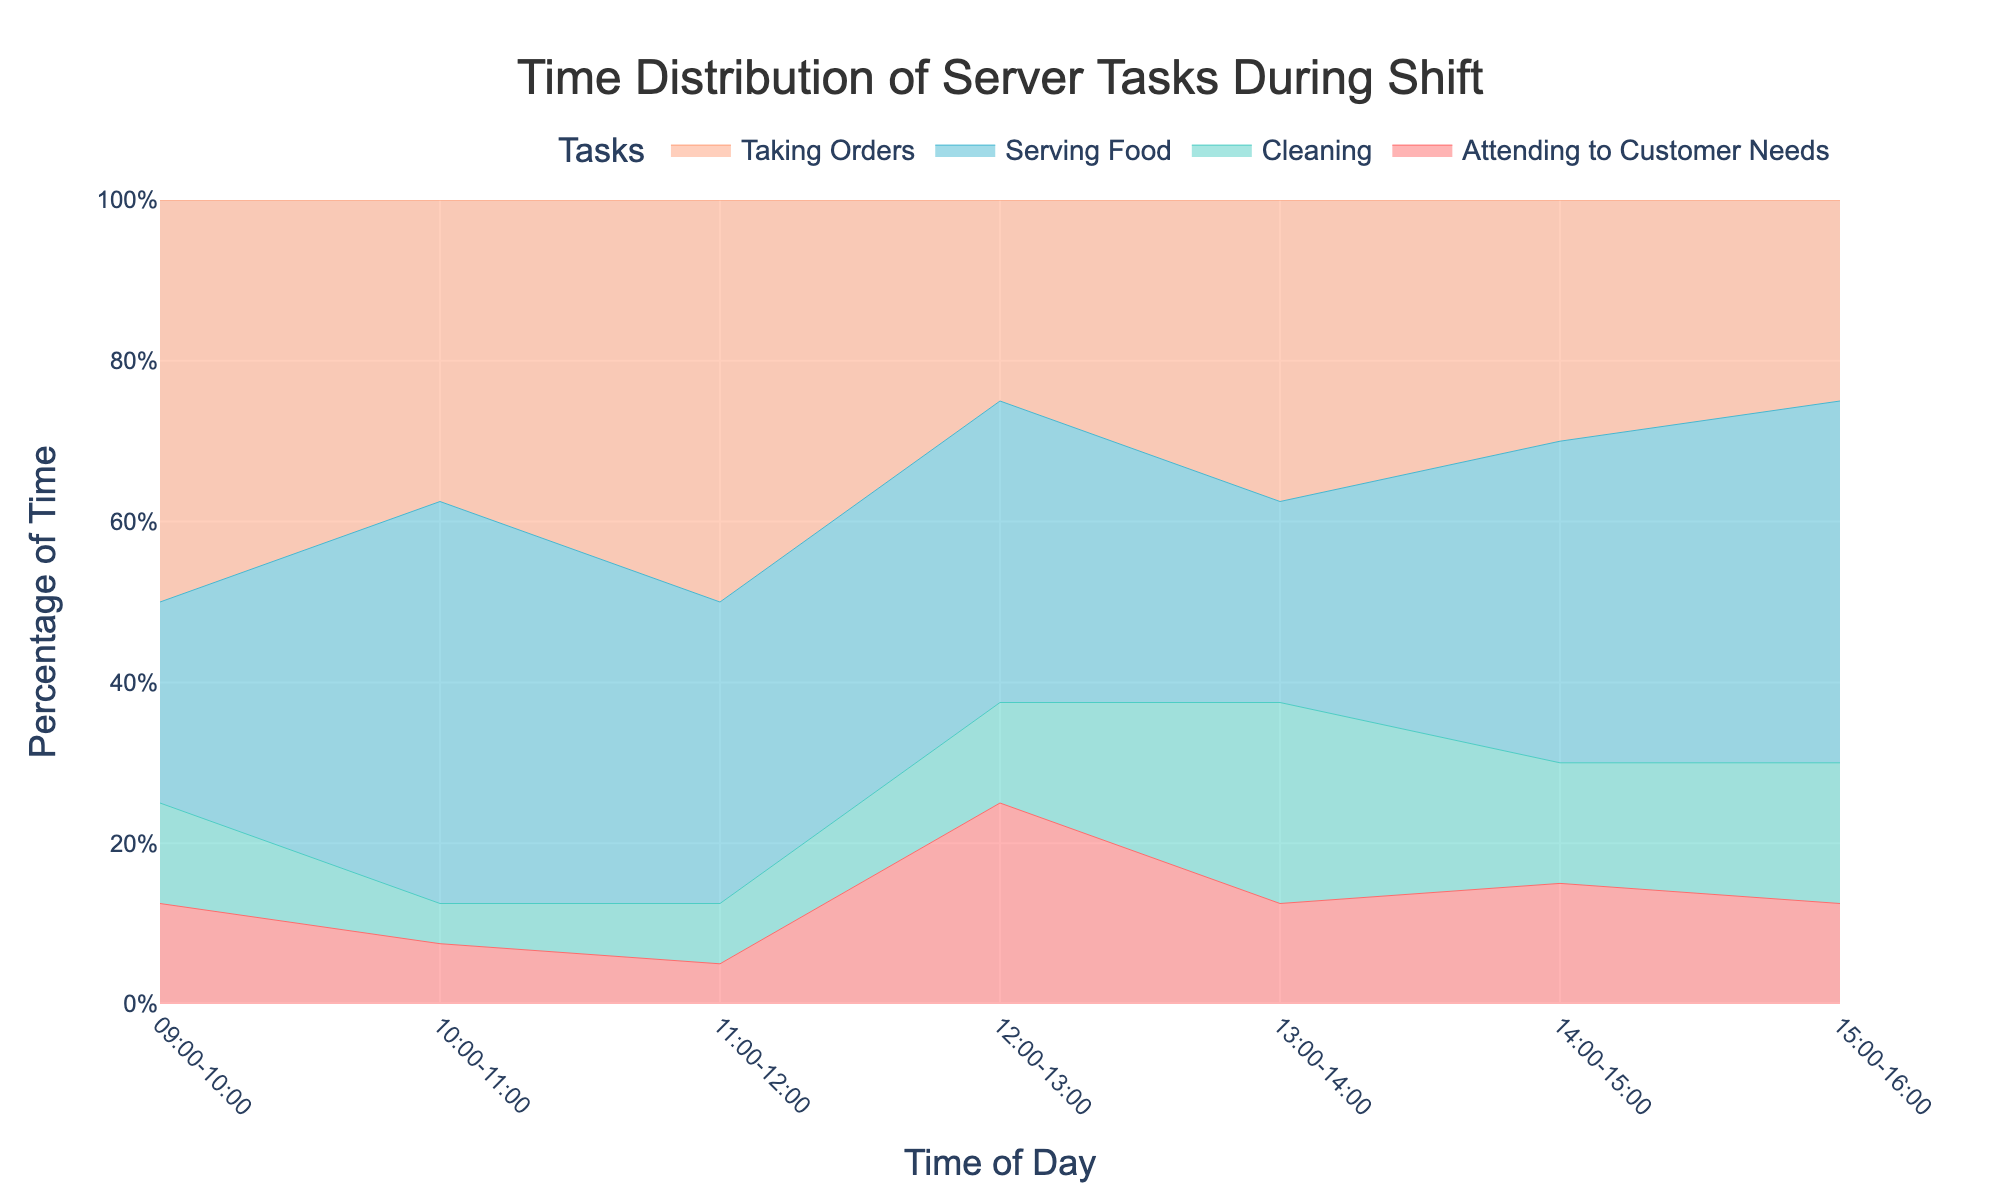What's the title of the figure? The title is usually displayed at the top center of the figure.
Answer: Time Distribution of Server Tasks During Shift What is the percentage of time spent on 'Taking Orders' between 14:00 and 15:00? Locate the period '14:00-15:00' on the x-axis and find the segment corresponding to 'Taking Orders' on the stacked area. Read the percentage from the y-axis grid lines.
Answer: 30% What task takes the most percentage of time during 12:00-13:00? Identify the 12:00-13:00 segment on the x-axis and determine which task segment extends furthest up, indicating the highest percentage.
Answer: Attending to Customer Needs What's the sum of percentages for 'Cleaning' from 10:00 to 12:00? Read the percentage values for 'Cleaning' at 10:00-11:00 (10%) and 11:00-12:00 (7.5%). Sum them up: 10% + 7.5%.
Answer: 17.5% Between which time slots is the 'Serving Food' task the most consistent in terms of percentage? Observe the 'Serving Food' percentage values across different time slots and identify where the percentages are most stable or change the least.
Answer: 13:00-15:00 Is there a time slot when 'Attending to Customer Needs' exceeded 25%? Check each time slot's 'Attending to Customer Needs' segment to see if it goes above 25%.
Answer: Yes, 12:00-13:00 Which task has the lowest percentage consistently throughout the shift? Examine the entire stack and determine which task stays at the bottom or occupies the smallest area consistently.
Answer: Cleaning How does the percentage of time spent on 'Taking Orders' at 09:00-10:00 compare with 15:00-16:00? Locate both time slots on the x-axis, compare the heights of 'Taking Orders' segments, and read their percentages. Compare the values.
Answer: Higher at 09:00-10:00 What's the total percentage change for 'Serving Food' from 09:00-10:00 to 10:00-11:00? Read the percentages for 'Serving Food' at those time slots: 09:00-10:00 (25%) and 10:00-11:00 (40%). Calculate the change: 40% - 25%.
Answer: 15% 